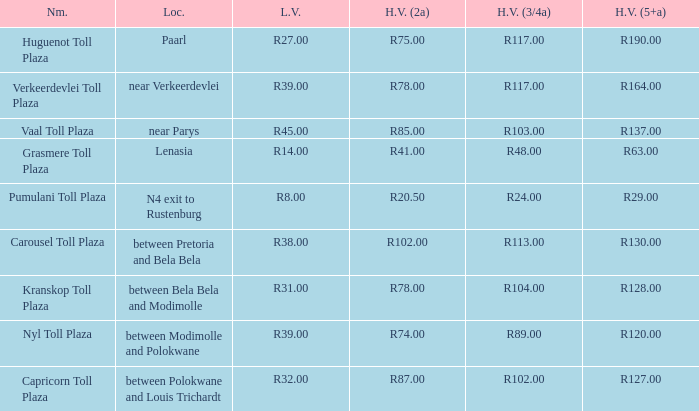What is the title of the public space where the fee for massive vehicles having 2 axles equals r8 Capricorn Toll Plaza. 